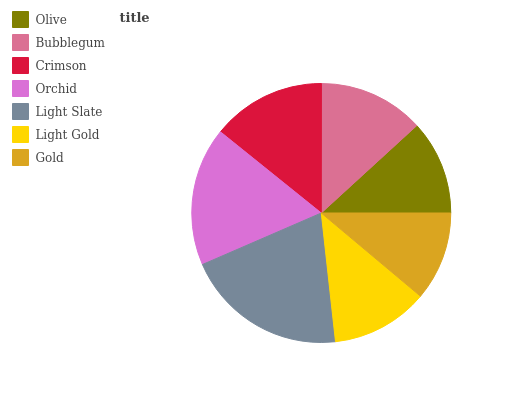Is Gold the minimum?
Answer yes or no. Yes. Is Light Slate the maximum?
Answer yes or no. Yes. Is Bubblegum the minimum?
Answer yes or no. No. Is Bubblegum the maximum?
Answer yes or no. No. Is Bubblegum greater than Olive?
Answer yes or no. Yes. Is Olive less than Bubblegum?
Answer yes or no. Yes. Is Olive greater than Bubblegum?
Answer yes or no. No. Is Bubblegum less than Olive?
Answer yes or no. No. Is Bubblegum the high median?
Answer yes or no. Yes. Is Bubblegum the low median?
Answer yes or no. Yes. Is Olive the high median?
Answer yes or no. No. Is Light Gold the low median?
Answer yes or no. No. 